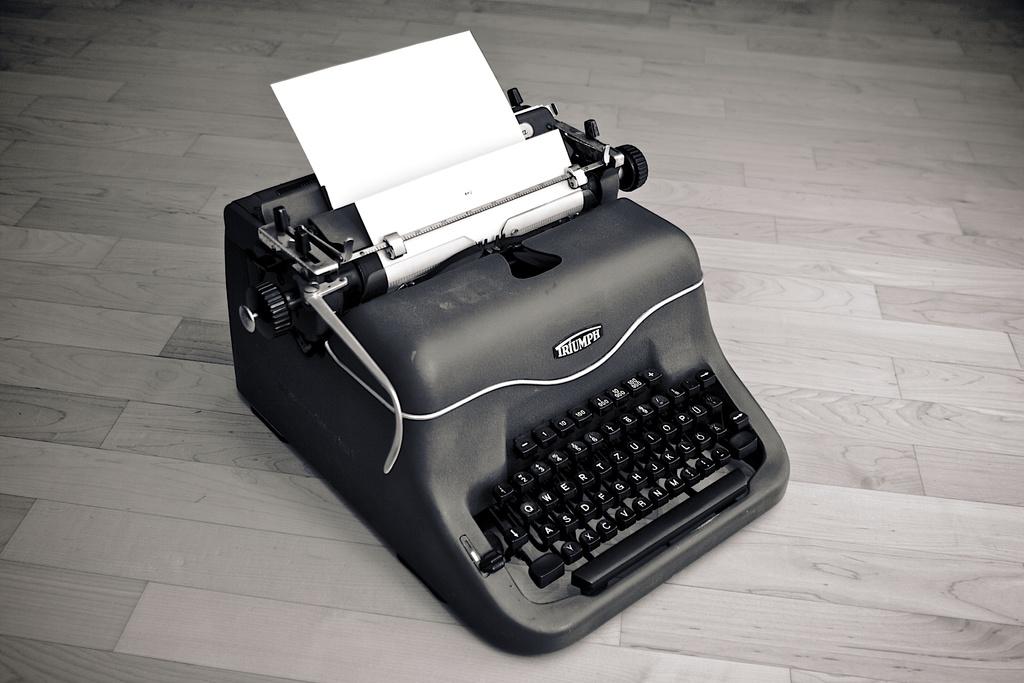What company made this typewriter?
Your answer should be compact. Triumph. 